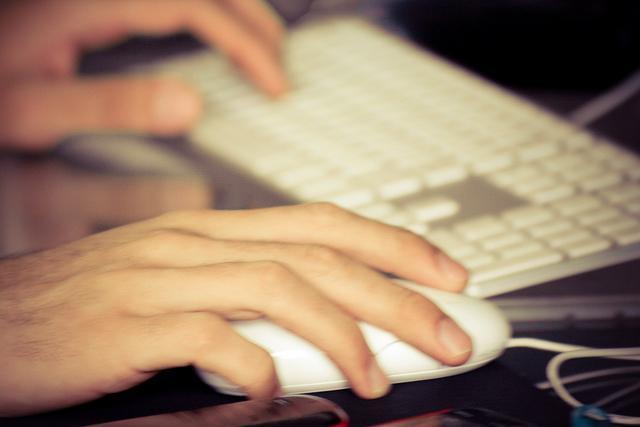How many mice are there?
Give a very brief answer. 1. 